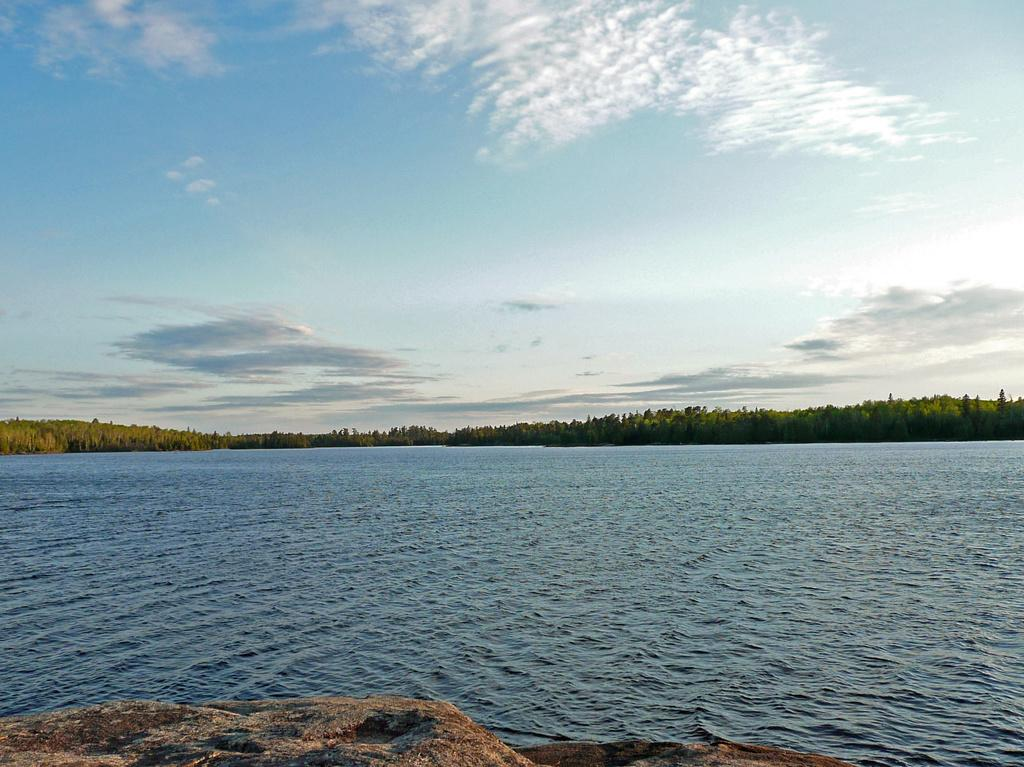What is the primary element visible in the image? There is water in the image. What type of vegetation can be seen in the image? There are trees in the image. What is present at the bottom of the image? There are stones at the bottom of the image. What is visible in the background of the image? The sky is visible in the image. What can be observed in the sky? Clouds are present in the sky. What unit is responsible for maintaining the water's temperature in the image? There is no mention of a unit responsible for maintaining the water's temperature in the image. 